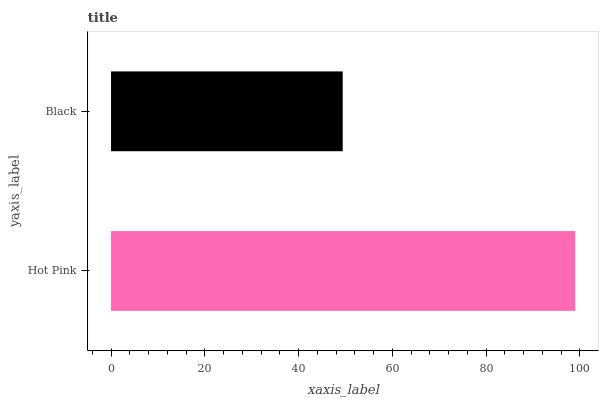Is Black the minimum?
Answer yes or no. Yes. Is Hot Pink the maximum?
Answer yes or no. Yes. Is Black the maximum?
Answer yes or no. No. Is Hot Pink greater than Black?
Answer yes or no. Yes. Is Black less than Hot Pink?
Answer yes or no. Yes. Is Black greater than Hot Pink?
Answer yes or no. No. Is Hot Pink less than Black?
Answer yes or no. No. Is Hot Pink the high median?
Answer yes or no. Yes. Is Black the low median?
Answer yes or no. Yes. Is Black the high median?
Answer yes or no. No. Is Hot Pink the low median?
Answer yes or no. No. 